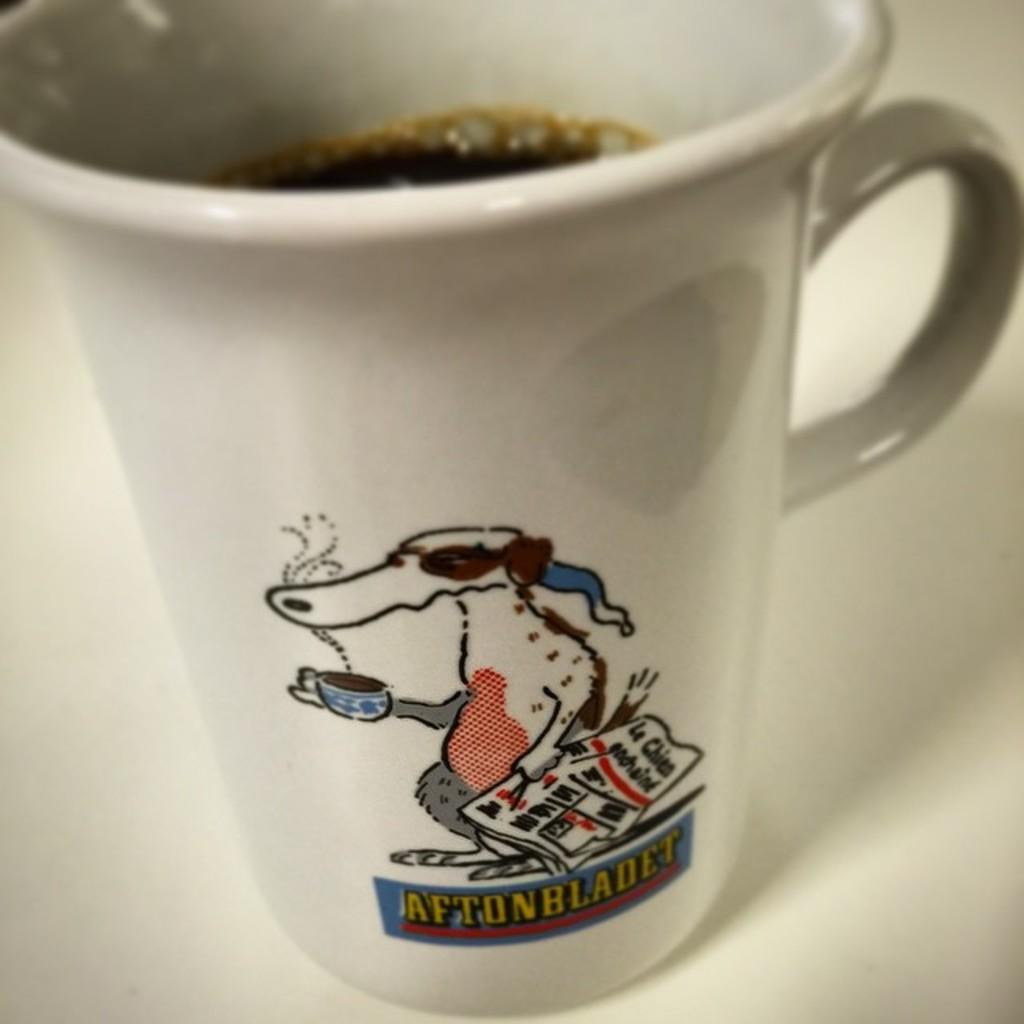What object is present in the image that can hold liquid? There is a cup in the image that can hold liquid. What color is the cup? The cup is white in color. What type of liquid is inside the cup? The cup contains black liquid. What color is the surface beneath the cup? The surface beneath the cup is white. What can be seen printed on the cup? There is something printed on the cup. What type of drum can be heard playing in the image? There is no drum present in the image, and therefore no sound can be heard. 